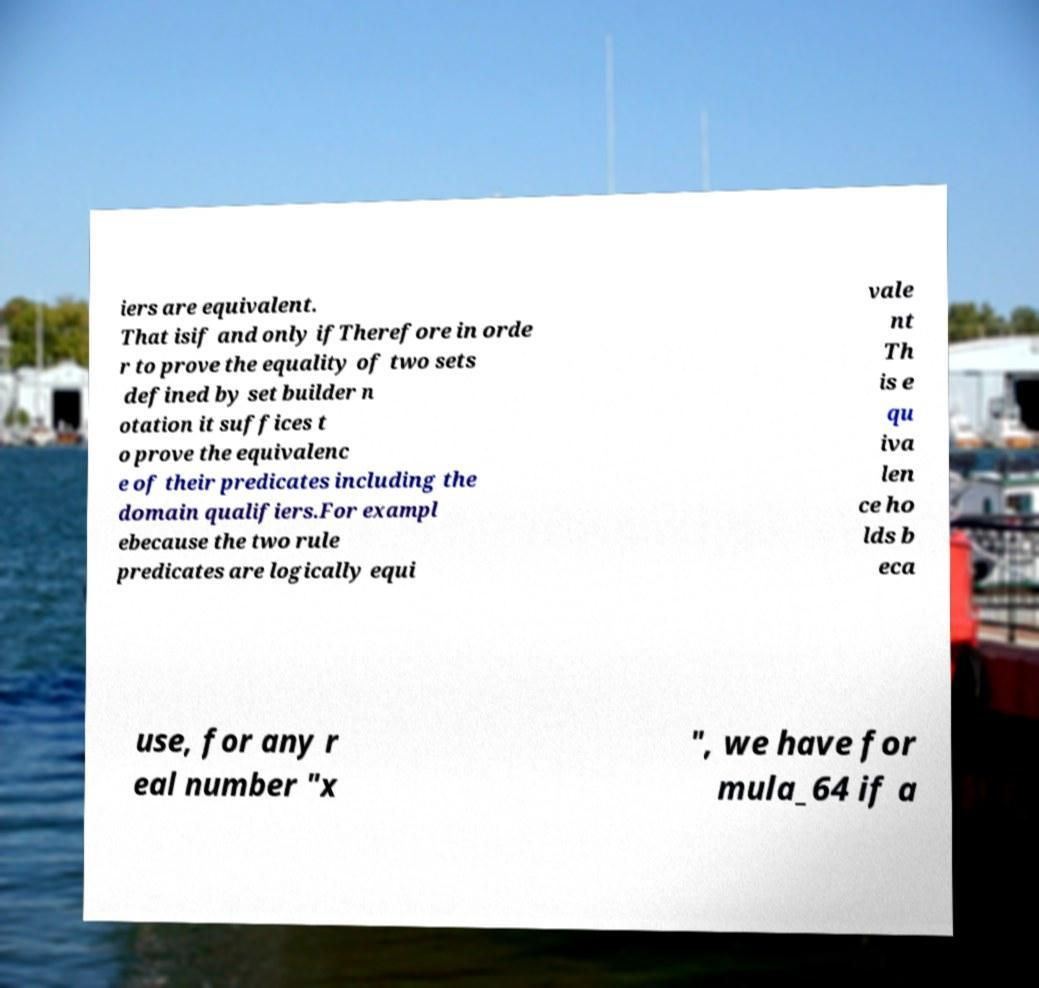There's text embedded in this image that I need extracted. Can you transcribe it verbatim? iers are equivalent. That isif and only ifTherefore in orde r to prove the equality of two sets defined by set builder n otation it suffices t o prove the equivalenc e of their predicates including the domain qualifiers.For exampl ebecause the two rule predicates are logically equi vale nt Th is e qu iva len ce ho lds b eca use, for any r eal number "x ", we have for mula_64 if a 